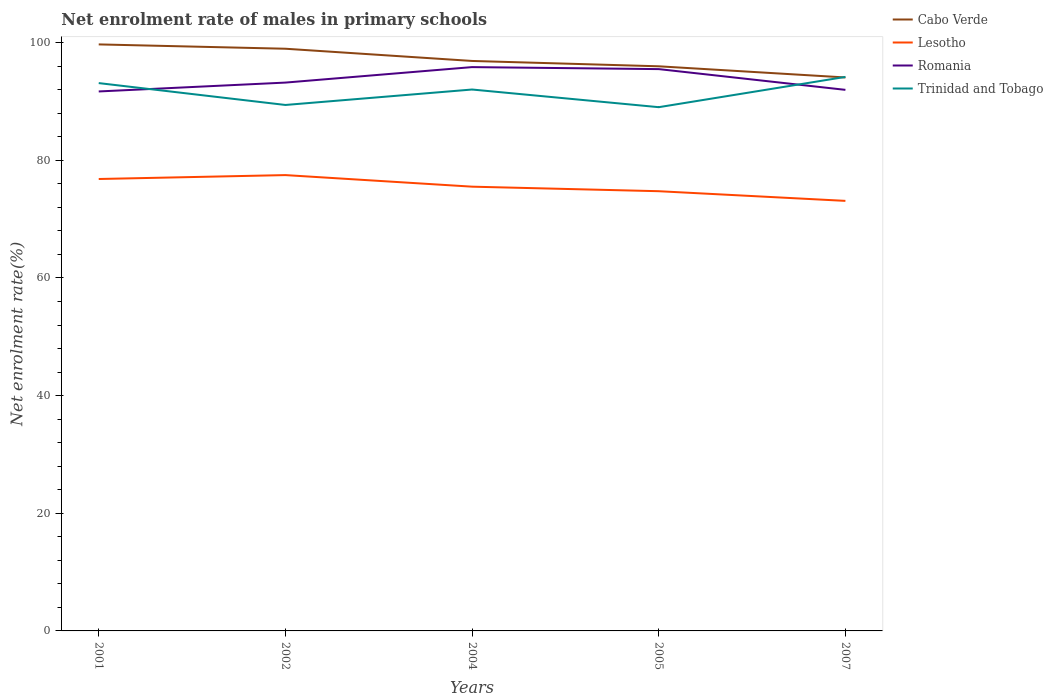Does the line corresponding to Cabo Verde intersect with the line corresponding to Lesotho?
Keep it short and to the point. No. Across all years, what is the maximum net enrolment rate of males in primary schools in Lesotho?
Your answer should be very brief. 73.11. In which year was the net enrolment rate of males in primary schools in Trinidad and Tobago maximum?
Give a very brief answer. 2005. What is the total net enrolment rate of males in primary schools in Lesotho in the graph?
Your response must be concise. 2.74. What is the difference between the highest and the second highest net enrolment rate of males in primary schools in Romania?
Offer a terse response. 4.14. What is the difference between two consecutive major ticks on the Y-axis?
Your answer should be very brief. 20. Does the graph contain any zero values?
Provide a succinct answer. No. Does the graph contain grids?
Offer a very short reply. No. How many legend labels are there?
Offer a very short reply. 4. What is the title of the graph?
Your response must be concise. Net enrolment rate of males in primary schools. What is the label or title of the Y-axis?
Your response must be concise. Net enrolment rate(%). What is the Net enrolment rate(%) in Cabo Verde in 2001?
Offer a terse response. 99.71. What is the Net enrolment rate(%) of Lesotho in 2001?
Make the answer very short. 76.82. What is the Net enrolment rate(%) of Romania in 2001?
Provide a succinct answer. 91.71. What is the Net enrolment rate(%) of Trinidad and Tobago in 2001?
Your response must be concise. 93.13. What is the Net enrolment rate(%) of Cabo Verde in 2002?
Keep it short and to the point. 98.97. What is the Net enrolment rate(%) of Lesotho in 2002?
Ensure brevity in your answer.  77.49. What is the Net enrolment rate(%) of Romania in 2002?
Your answer should be very brief. 93.21. What is the Net enrolment rate(%) of Trinidad and Tobago in 2002?
Make the answer very short. 89.41. What is the Net enrolment rate(%) in Cabo Verde in 2004?
Keep it short and to the point. 96.89. What is the Net enrolment rate(%) in Lesotho in 2004?
Provide a succinct answer. 75.52. What is the Net enrolment rate(%) of Romania in 2004?
Offer a very short reply. 95.85. What is the Net enrolment rate(%) of Trinidad and Tobago in 2004?
Ensure brevity in your answer.  92.04. What is the Net enrolment rate(%) of Cabo Verde in 2005?
Your response must be concise. 95.98. What is the Net enrolment rate(%) in Lesotho in 2005?
Offer a terse response. 74.75. What is the Net enrolment rate(%) in Romania in 2005?
Offer a very short reply. 95.51. What is the Net enrolment rate(%) of Trinidad and Tobago in 2005?
Your response must be concise. 89.03. What is the Net enrolment rate(%) in Cabo Verde in 2007?
Your answer should be compact. 94.08. What is the Net enrolment rate(%) of Lesotho in 2007?
Keep it short and to the point. 73.11. What is the Net enrolment rate(%) in Romania in 2007?
Provide a short and direct response. 91.98. What is the Net enrolment rate(%) of Trinidad and Tobago in 2007?
Offer a very short reply. 94.18. Across all years, what is the maximum Net enrolment rate(%) in Cabo Verde?
Give a very brief answer. 99.71. Across all years, what is the maximum Net enrolment rate(%) in Lesotho?
Give a very brief answer. 77.49. Across all years, what is the maximum Net enrolment rate(%) of Romania?
Keep it short and to the point. 95.85. Across all years, what is the maximum Net enrolment rate(%) of Trinidad and Tobago?
Give a very brief answer. 94.18. Across all years, what is the minimum Net enrolment rate(%) in Cabo Verde?
Offer a terse response. 94.08. Across all years, what is the minimum Net enrolment rate(%) of Lesotho?
Your answer should be compact. 73.11. Across all years, what is the minimum Net enrolment rate(%) in Romania?
Make the answer very short. 91.71. Across all years, what is the minimum Net enrolment rate(%) of Trinidad and Tobago?
Offer a terse response. 89.03. What is the total Net enrolment rate(%) of Cabo Verde in the graph?
Make the answer very short. 485.63. What is the total Net enrolment rate(%) of Lesotho in the graph?
Give a very brief answer. 377.69. What is the total Net enrolment rate(%) of Romania in the graph?
Offer a very short reply. 468.25. What is the total Net enrolment rate(%) of Trinidad and Tobago in the graph?
Ensure brevity in your answer.  457.79. What is the difference between the Net enrolment rate(%) in Cabo Verde in 2001 and that in 2002?
Make the answer very short. 0.74. What is the difference between the Net enrolment rate(%) of Lesotho in 2001 and that in 2002?
Your answer should be compact. -0.66. What is the difference between the Net enrolment rate(%) of Romania in 2001 and that in 2002?
Ensure brevity in your answer.  -1.51. What is the difference between the Net enrolment rate(%) of Trinidad and Tobago in 2001 and that in 2002?
Your answer should be compact. 3.72. What is the difference between the Net enrolment rate(%) in Cabo Verde in 2001 and that in 2004?
Keep it short and to the point. 2.81. What is the difference between the Net enrolment rate(%) of Lesotho in 2001 and that in 2004?
Ensure brevity in your answer.  1.3. What is the difference between the Net enrolment rate(%) of Romania in 2001 and that in 2004?
Keep it short and to the point. -4.14. What is the difference between the Net enrolment rate(%) of Trinidad and Tobago in 2001 and that in 2004?
Provide a succinct answer. 1.09. What is the difference between the Net enrolment rate(%) of Cabo Verde in 2001 and that in 2005?
Make the answer very short. 3.72. What is the difference between the Net enrolment rate(%) of Lesotho in 2001 and that in 2005?
Keep it short and to the point. 2.07. What is the difference between the Net enrolment rate(%) of Romania in 2001 and that in 2005?
Offer a terse response. -3.8. What is the difference between the Net enrolment rate(%) of Trinidad and Tobago in 2001 and that in 2005?
Make the answer very short. 4.09. What is the difference between the Net enrolment rate(%) in Cabo Verde in 2001 and that in 2007?
Give a very brief answer. 5.62. What is the difference between the Net enrolment rate(%) in Lesotho in 2001 and that in 2007?
Keep it short and to the point. 3.72. What is the difference between the Net enrolment rate(%) of Romania in 2001 and that in 2007?
Provide a short and direct response. -0.27. What is the difference between the Net enrolment rate(%) in Trinidad and Tobago in 2001 and that in 2007?
Give a very brief answer. -1.05. What is the difference between the Net enrolment rate(%) in Cabo Verde in 2002 and that in 2004?
Provide a short and direct response. 2.08. What is the difference between the Net enrolment rate(%) of Lesotho in 2002 and that in 2004?
Your answer should be compact. 1.97. What is the difference between the Net enrolment rate(%) of Romania in 2002 and that in 2004?
Your answer should be very brief. -2.63. What is the difference between the Net enrolment rate(%) in Trinidad and Tobago in 2002 and that in 2004?
Your response must be concise. -2.63. What is the difference between the Net enrolment rate(%) in Cabo Verde in 2002 and that in 2005?
Give a very brief answer. 2.99. What is the difference between the Net enrolment rate(%) of Lesotho in 2002 and that in 2005?
Ensure brevity in your answer.  2.74. What is the difference between the Net enrolment rate(%) of Romania in 2002 and that in 2005?
Your answer should be very brief. -2.29. What is the difference between the Net enrolment rate(%) of Trinidad and Tobago in 2002 and that in 2005?
Offer a terse response. 0.38. What is the difference between the Net enrolment rate(%) of Cabo Verde in 2002 and that in 2007?
Your answer should be compact. 4.88. What is the difference between the Net enrolment rate(%) in Lesotho in 2002 and that in 2007?
Your response must be concise. 4.38. What is the difference between the Net enrolment rate(%) of Romania in 2002 and that in 2007?
Offer a very short reply. 1.24. What is the difference between the Net enrolment rate(%) in Trinidad and Tobago in 2002 and that in 2007?
Offer a terse response. -4.77. What is the difference between the Net enrolment rate(%) of Cabo Verde in 2004 and that in 2005?
Your response must be concise. 0.91. What is the difference between the Net enrolment rate(%) of Lesotho in 2004 and that in 2005?
Keep it short and to the point. 0.77. What is the difference between the Net enrolment rate(%) of Romania in 2004 and that in 2005?
Your answer should be compact. 0.34. What is the difference between the Net enrolment rate(%) in Trinidad and Tobago in 2004 and that in 2005?
Your answer should be compact. 3. What is the difference between the Net enrolment rate(%) of Cabo Verde in 2004 and that in 2007?
Offer a very short reply. 2.81. What is the difference between the Net enrolment rate(%) in Lesotho in 2004 and that in 2007?
Offer a very short reply. 2.42. What is the difference between the Net enrolment rate(%) in Romania in 2004 and that in 2007?
Give a very brief answer. 3.87. What is the difference between the Net enrolment rate(%) of Trinidad and Tobago in 2004 and that in 2007?
Ensure brevity in your answer.  -2.14. What is the difference between the Net enrolment rate(%) in Cabo Verde in 2005 and that in 2007?
Your answer should be compact. 1.9. What is the difference between the Net enrolment rate(%) in Lesotho in 2005 and that in 2007?
Your answer should be very brief. 1.64. What is the difference between the Net enrolment rate(%) in Romania in 2005 and that in 2007?
Your answer should be compact. 3.53. What is the difference between the Net enrolment rate(%) of Trinidad and Tobago in 2005 and that in 2007?
Your answer should be compact. -5.15. What is the difference between the Net enrolment rate(%) in Cabo Verde in 2001 and the Net enrolment rate(%) in Lesotho in 2002?
Offer a very short reply. 22.22. What is the difference between the Net enrolment rate(%) of Cabo Verde in 2001 and the Net enrolment rate(%) of Romania in 2002?
Offer a terse response. 6.49. What is the difference between the Net enrolment rate(%) in Cabo Verde in 2001 and the Net enrolment rate(%) in Trinidad and Tobago in 2002?
Offer a terse response. 10.3. What is the difference between the Net enrolment rate(%) of Lesotho in 2001 and the Net enrolment rate(%) of Romania in 2002?
Keep it short and to the point. -16.39. What is the difference between the Net enrolment rate(%) of Lesotho in 2001 and the Net enrolment rate(%) of Trinidad and Tobago in 2002?
Make the answer very short. -12.59. What is the difference between the Net enrolment rate(%) in Romania in 2001 and the Net enrolment rate(%) in Trinidad and Tobago in 2002?
Give a very brief answer. 2.3. What is the difference between the Net enrolment rate(%) of Cabo Verde in 2001 and the Net enrolment rate(%) of Lesotho in 2004?
Keep it short and to the point. 24.18. What is the difference between the Net enrolment rate(%) in Cabo Verde in 2001 and the Net enrolment rate(%) in Romania in 2004?
Your answer should be compact. 3.86. What is the difference between the Net enrolment rate(%) of Cabo Verde in 2001 and the Net enrolment rate(%) of Trinidad and Tobago in 2004?
Provide a short and direct response. 7.67. What is the difference between the Net enrolment rate(%) of Lesotho in 2001 and the Net enrolment rate(%) of Romania in 2004?
Offer a very short reply. -19.02. What is the difference between the Net enrolment rate(%) in Lesotho in 2001 and the Net enrolment rate(%) in Trinidad and Tobago in 2004?
Provide a succinct answer. -15.21. What is the difference between the Net enrolment rate(%) in Romania in 2001 and the Net enrolment rate(%) in Trinidad and Tobago in 2004?
Give a very brief answer. -0.33. What is the difference between the Net enrolment rate(%) in Cabo Verde in 2001 and the Net enrolment rate(%) in Lesotho in 2005?
Your response must be concise. 24.96. What is the difference between the Net enrolment rate(%) in Cabo Verde in 2001 and the Net enrolment rate(%) in Romania in 2005?
Your response must be concise. 4.2. What is the difference between the Net enrolment rate(%) in Cabo Verde in 2001 and the Net enrolment rate(%) in Trinidad and Tobago in 2005?
Your answer should be compact. 10.67. What is the difference between the Net enrolment rate(%) of Lesotho in 2001 and the Net enrolment rate(%) of Romania in 2005?
Give a very brief answer. -18.68. What is the difference between the Net enrolment rate(%) in Lesotho in 2001 and the Net enrolment rate(%) in Trinidad and Tobago in 2005?
Make the answer very short. -12.21. What is the difference between the Net enrolment rate(%) of Romania in 2001 and the Net enrolment rate(%) of Trinidad and Tobago in 2005?
Offer a very short reply. 2.67. What is the difference between the Net enrolment rate(%) of Cabo Verde in 2001 and the Net enrolment rate(%) of Lesotho in 2007?
Your answer should be very brief. 26.6. What is the difference between the Net enrolment rate(%) of Cabo Verde in 2001 and the Net enrolment rate(%) of Romania in 2007?
Keep it short and to the point. 7.73. What is the difference between the Net enrolment rate(%) in Cabo Verde in 2001 and the Net enrolment rate(%) in Trinidad and Tobago in 2007?
Offer a terse response. 5.53. What is the difference between the Net enrolment rate(%) in Lesotho in 2001 and the Net enrolment rate(%) in Romania in 2007?
Give a very brief answer. -15.15. What is the difference between the Net enrolment rate(%) in Lesotho in 2001 and the Net enrolment rate(%) in Trinidad and Tobago in 2007?
Provide a short and direct response. -17.36. What is the difference between the Net enrolment rate(%) in Romania in 2001 and the Net enrolment rate(%) in Trinidad and Tobago in 2007?
Make the answer very short. -2.47. What is the difference between the Net enrolment rate(%) in Cabo Verde in 2002 and the Net enrolment rate(%) in Lesotho in 2004?
Your response must be concise. 23.45. What is the difference between the Net enrolment rate(%) of Cabo Verde in 2002 and the Net enrolment rate(%) of Romania in 2004?
Your response must be concise. 3.12. What is the difference between the Net enrolment rate(%) of Cabo Verde in 2002 and the Net enrolment rate(%) of Trinidad and Tobago in 2004?
Give a very brief answer. 6.93. What is the difference between the Net enrolment rate(%) in Lesotho in 2002 and the Net enrolment rate(%) in Romania in 2004?
Offer a terse response. -18.36. What is the difference between the Net enrolment rate(%) of Lesotho in 2002 and the Net enrolment rate(%) of Trinidad and Tobago in 2004?
Provide a succinct answer. -14.55. What is the difference between the Net enrolment rate(%) of Romania in 2002 and the Net enrolment rate(%) of Trinidad and Tobago in 2004?
Keep it short and to the point. 1.18. What is the difference between the Net enrolment rate(%) of Cabo Verde in 2002 and the Net enrolment rate(%) of Lesotho in 2005?
Ensure brevity in your answer.  24.22. What is the difference between the Net enrolment rate(%) in Cabo Verde in 2002 and the Net enrolment rate(%) in Romania in 2005?
Make the answer very short. 3.46. What is the difference between the Net enrolment rate(%) of Cabo Verde in 2002 and the Net enrolment rate(%) of Trinidad and Tobago in 2005?
Give a very brief answer. 9.93. What is the difference between the Net enrolment rate(%) in Lesotho in 2002 and the Net enrolment rate(%) in Romania in 2005?
Ensure brevity in your answer.  -18.02. What is the difference between the Net enrolment rate(%) of Lesotho in 2002 and the Net enrolment rate(%) of Trinidad and Tobago in 2005?
Provide a succinct answer. -11.55. What is the difference between the Net enrolment rate(%) of Romania in 2002 and the Net enrolment rate(%) of Trinidad and Tobago in 2005?
Give a very brief answer. 4.18. What is the difference between the Net enrolment rate(%) in Cabo Verde in 2002 and the Net enrolment rate(%) in Lesotho in 2007?
Provide a short and direct response. 25.86. What is the difference between the Net enrolment rate(%) in Cabo Verde in 2002 and the Net enrolment rate(%) in Romania in 2007?
Offer a terse response. 6.99. What is the difference between the Net enrolment rate(%) of Cabo Verde in 2002 and the Net enrolment rate(%) of Trinidad and Tobago in 2007?
Your answer should be compact. 4.79. What is the difference between the Net enrolment rate(%) of Lesotho in 2002 and the Net enrolment rate(%) of Romania in 2007?
Keep it short and to the point. -14.49. What is the difference between the Net enrolment rate(%) of Lesotho in 2002 and the Net enrolment rate(%) of Trinidad and Tobago in 2007?
Your answer should be compact. -16.69. What is the difference between the Net enrolment rate(%) of Romania in 2002 and the Net enrolment rate(%) of Trinidad and Tobago in 2007?
Offer a very short reply. -0.96. What is the difference between the Net enrolment rate(%) of Cabo Verde in 2004 and the Net enrolment rate(%) of Lesotho in 2005?
Make the answer very short. 22.14. What is the difference between the Net enrolment rate(%) of Cabo Verde in 2004 and the Net enrolment rate(%) of Romania in 2005?
Provide a short and direct response. 1.38. What is the difference between the Net enrolment rate(%) of Cabo Verde in 2004 and the Net enrolment rate(%) of Trinidad and Tobago in 2005?
Your answer should be compact. 7.86. What is the difference between the Net enrolment rate(%) in Lesotho in 2004 and the Net enrolment rate(%) in Romania in 2005?
Your response must be concise. -19.98. What is the difference between the Net enrolment rate(%) in Lesotho in 2004 and the Net enrolment rate(%) in Trinidad and Tobago in 2005?
Give a very brief answer. -13.51. What is the difference between the Net enrolment rate(%) of Romania in 2004 and the Net enrolment rate(%) of Trinidad and Tobago in 2005?
Keep it short and to the point. 6.81. What is the difference between the Net enrolment rate(%) of Cabo Verde in 2004 and the Net enrolment rate(%) of Lesotho in 2007?
Ensure brevity in your answer.  23.79. What is the difference between the Net enrolment rate(%) in Cabo Verde in 2004 and the Net enrolment rate(%) in Romania in 2007?
Make the answer very short. 4.91. What is the difference between the Net enrolment rate(%) of Cabo Verde in 2004 and the Net enrolment rate(%) of Trinidad and Tobago in 2007?
Provide a short and direct response. 2.71. What is the difference between the Net enrolment rate(%) in Lesotho in 2004 and the Net enrolment rate(%) in Romania in 2007?
Offer a terse response. -16.46. What is the difference between the Net enrolment rate(%) of Lesotho in 2004 and the Net enrolment rate(%) of Trinidad and Tobago in 2007?
Your answer should be compact. -18.66. What is the difference between the Net enrolment rate(%) in Romania in 2004 and the Net enrolment rate(%) in Trinidad and Tobago in 2007?
Offer a very short reply. 1.67. What is the difference between the Net enrolment rate(%) of Cabo Verde in 2005 and the Net enrolment rate(%) of Lesotho in 2007?
Give a very brief answer. 22.88. What is the difference between the Net enrolment rate(%) of Cabo Verde in 2005 and the Net enrolment rate(%) of Romania in 2007?
Provide a succinct answer. 4. What is the difference between the Net enrolment rate(%) in Cabo Verde in 2005 and the Net enrolment rate(%) in Trinidad and Tobago in 2007?
Your answer should be very brief. 1.8. What is the difference between the Net enrolment rate(%) in Lesotho in 2005 and the Net enrolment rate(%) in Romania in 2007?
Provide a succinct answer. -17.23. What is the difference between the Net enrolment rate(%) of Lesotho in 2005 and the Net enrolment rate(%) of Trinidad and Tobago in 2007?
Your response must be concise. -19.43. What is the difference between the Net enrolment rate(%) of Romania in 2005 and the Net enrolment rate(%) of Trinidad and Tobago in 2007?
Keep it short and to the point. 1.33. What is the average Net enrolment rate(%) of Cabo Verde per year?
Provide a succinct answer. 97.13. What is the average Net enrolment rate(%) in Lesotho per year?
Offer a terse response. 75.54. What is the average Net enrolment rate(%) of Romania per year?
Provide a short and direct response. 93.65. What is the average Net enrolment rate(%) in Trinidad and Tobago per year?
Your response must be concise. 91.56. In the year 2001, what is the difference between the Net enrolment rate(%) in Cabo Verde and Net enrolment rate(%) in Lesotho?
Ensure brevity in your answer.  22.88. In the year 2001, what is the difference between the Net enrolment rate(%) in Cabo Verde and Net enrolment rate(%) in Romania?
Your answer should be very brief. 8. In the year 2001, what is the difference between the Net enrolment rate(%) of Cabo Verde and Net enrolment rate(%) of Trinidad and Tobago?
Offer a terse response. 6.58. In the year 2001, what is the difference between the Net enrolment rate(%) in Lesotho and Net enrolment rate(%) in Romania?
Keep it short and to the point. -14.88. In the year 2001, what is the difference between the Net enrolment rate(%) of Lesotho and Net enrolment rate(%) of Trinidad and Tobago?
Make the answer very short. -16.3. In the year 2001, what is the difference between the Net enrolment rate(%) of Romania and Net enrolment rate(%) of Trinidad and Tobago?
Give a very brief answer. -1.42. In the year 2002, what is the difference between the Net enrolment rate(%) of Cabo Verde and Net enrolment rate(%) of Lesotho?
Your answer should be compact. 21.48. In the year 2002, what is the difference between the Net enrolment rate(%) of Cabo Verde and Net enrolment rate(%) of Romania?
Your response must be concise. 5.75. In the year 2002, what is the difference between the Net enrolment rate(%) of Cabo Verde and Net enrolment rate(%) of Trinidad and Tobago?
Your response must be concise. 9.56. In the year 2002, what is the difference between the Net enrolment rate(%) of Lesotho and Net enrolment rate(%) of Romania?
Your answer should be compact. -15.73. In the year 2002, what is the difference between the Net enrolment rate(%) in Lesotho and Net enrolment rate(%) in Trinidad and Tobago?
Provide a succinct answer. -11.92. In the year 2002, what is the difference between the Net enrolment rate(%) in Romania and Net enrolment rate(%) in Trinidad and Tobago?
Offer a very short reply. 3.8. In the year 2004, what is the difference between the Net enrolment rate(%) of Cabo Verde and Net enrolment rate(%) of Lesotho?
Your response must be concise. 21.37. In the year 2004, what is the difference between the Net enrolment rate(%) of Cabo Verde and Net enrolment rate(%) of Romania?
Give a very brief answer. 1.04. In the year 2004, what is the difference between the Net enrolment rate(%) in Cabo Verde and Net enrolment rate(%) in Trinidad and Tobago?
Give a very brief answer. 4.85. In the year 2004, what is the difference between the Net enrolment rate(%) of Lesotho and Net enrolment rate(%) of Romania?
Provide a succinct answer. -20.32. In the year 2004, what is the difference between the Net enrolment rate(%) in Lesotho and Net enrolment rate(%) in Trinidad and Tobago?
Ensure brevity in your answer.  -16.52. In the year 2004, what is the difference between the Net enrolment rate(%) in Romania and Net enrolment rate(%) in Trinidad and Tobago?
Offer a very short reply. 3.81. In the year 2005, what is the difference between the Net enrolment rate(%) of Cabo Verde and Net enrolment rate(%) of Lesotho?
Your response must be concise. 21.23. In the year 2005, what is the difference between the Net enrolment rate(%) of Cabo Verde and Net enrolment rate(%) of Romania?
Offer a very short reply. 0.48. In the year 2005, what is the difference between the Net enrolment rate(%) in Cabo Verde and Net enrolment rate(%) in Trinidad and Tobago?
Offer a terse response. 6.95. In the year 2005, what is the difference between the Net enrolment rate(%) of Lesotho and Net enrolment rate(%) of Romania?
Your answer should be very brief. -20.76. In the year 2005, what is the difference between the Net enrolment rate(%) of Lesotho and Net enrolment rate(%) of Trinidad and Tobago?
Your response must be concise. -14.28. In the year 2005, what is the difference between the Net enrolment rate(%) in Romania and Net enrolment rate(%) in Trinidad and Tobago?
Your answer should be very brief. 6.47. In the year 2007, what is the difference between the Net enrolment rate(%) of Cabo Verde and Net enrolment rate(%) of Lesotho?
Your answer should be compact. 20.98. In the year 2007, what is the difference between the Net enrolment rate(%) of Cabo Verde and Net enrolment rate(%) of Romania?
Your answer should be compact. 2.11. In the year 2007, what is the difference between the Net enrolment rate(%) of Cabo Verde and Net enrolment rate(%) of Trinidad and Tobago?
Offer a very short reply. -0.1. In the year 2007, what is the difference between the Net enrolment rate(%) in Lesotho and Net enrolment rate(%) in Romania?
Give a very brief answer. -18.87. In the year 2007, what is the difference between the Net enrolment rate(%) in Lesotho and Net enrolment rate(%) in Trinidad and Tobago?
Provide a short and direct response. -21.07. In the year 2007, what is the difference between the Net enrolment rate(%) of Romania and Net enrolment rate(%) of Trinidad and Tobago?
Offer a very short reply. -2.2. What is the ratio of the Net enrolment rate(%) in Cabo Verde in 2001 to that in 2002?
Ensure brevity in your answer.  1.01. What is the ratio of the Net enrolment rate(%) in Romania in 2001 to that in 2002?
Give a very brief answer. 0.98. What is the ratio of the Net enrolment rate(%) of Trinidad and Tobago in 2001 to that in 2002?
Offer a very short reply. 1.04. What is the ratio of the Net enrolment rate(%) of Cabo Verde in 2001 to that in 2004?
Offer a very short reply. 1.03. What is the ratio of the Net enrolment rate(%) of Lesotho in 2001 to that in 2004?
Offer a terse response. 1.02. What is the ratio of the Net enrolment rate(%) in Romania in 2001 to that in 2004?
Ensure brevity in your answer.  0.96. What is the ratio of the Net enrolment rate(%) of Trinidad and Tobago in 2001 to that in 2004?
Your answer should be compact. 1.01. What is the ratio of the Net enrolment rate(%) of Cabo Verde in 2001 to that in 2005?
Offer a terse response. 1.04. What is the ratio of the Net enrolment rate(%) of Lesotho in 2001 to that in 2005?
Make the answer very short. 1.03. What is the ratio of the Net enrolment rate(%) in Romania in 2001 to that in 2005?
Make the answer very short. 0.96. What is the ratio of the Net enrolment rate(%) in Trinidad and Tobago in 2001 to that in 2005?
Provide a succinct answer. 1.05. What is the ratio of the Net enrolment rate(%) of Cabo Verde in 2001 to that in 2007?
Your response must be concise. 1.06. What is the ratio of the Net enrolment rate(%) of Lesotho in 2001 to that in 2007?
Your answer should be very brief. 1.05. What is the ratio of the Net enrolment rate(%) of Cabo Verde in 2002 to that in 2004?
Ensure brevity in your answer.  1.02. What is the ratio of the Net enrolment rate(%) in Romania in 2002 to that in 2004?
Ensure brevity in your answer.  0.97. What is the ratio of the Net enrolment rate(%) in Trinidad and Tobago in 2002 to that in 2004?
Give a very brief answer. 0.97. What is the ratio of the Net enrolment rate(%) in Cabo Verde in 2002 to that in 2005?
Keep it short and to the point. 1.03. What is the ratio of the Net enrolment rate(%) in Lesotho in 2002 to that in 2005?
Make the answer very short. 1.04. What is the ratio of the Net enrolment rate(%) in Trinidad and Tobago in 2002 to that in 2005?
Give a very brief answer. 1. What is the ratio of the Net enrolment rate(%) in Cabo Verde in 2002 to that in 2007?
Provide a succinct answer. 1.05. What is the ratio of the Net enrolment rate(%) in Lesotho in 2002 to that in 2007?
Make the answer very short. 1.06. What is the ratio of the Net enrolment rate(%) in Romania in 2002 to that in 2007?
Your answer should be compact. 1.01. What is the ratio of the Net enrolment rate(%) of Trinidad and Tobago in 2002 to that in 2007?
Provide a succinct answer. 0.95. What is the ratio of the Net enrolment rate(%) of Cabo Verde in 2004 to that in 2005?
Make the answer very short. 1.01. What is the ratio of the Net enrolment rate(%) of Lesotho in 2004 to that in 2005?
Make the answer very short. 1.01. What is the ratio of the Net enrolment rate(%) in Romania in 2004 to that in 2005?
Provide a succinct answer. 1. What is the ratio of the Net enrolment rate(%) in Trinidad and Tobago in 2004 to that in 2005?
Offer a very short reply. 1.03. What is the ratio of the Net enrolment rate(%) in Cabo Verde in 2004 to that in 2007?
Ensure brevity in your answer.  1.03. What is the ratio of the Net enrolment rate(%) in Lesotho in 2004 to that in 2007?
Ensure brevity in your answer.  1.03. What is the ratio of the Net enrolment rate(%) in Romania in 2004 to that in 2007?
Keep it short and to the point. 1.04. What is the ratio of the Net enrolment rate(%) of Trinidad and Tobago in 2004 to that in 2007?
Offer a terse response. 0.98. What is the ratio of the Net enrolment rate(%) of Cabo Verde in 2005 to that in 2007?
Your answer should be compact. 1.02. What is the ratio of the Net enrolment rate(%) in Lesotho in 2005 to that in 2007?
Your answer should be very brief. 1.02. What is the ratio of the Net enrolment rate(%) in Romania in 2005 to that in 2007?
Ensure brevity in your answer.  1.04. What is the ratio of the Net enrolment rate(%) in Trinidad and Tobago in 2005 to that in 2007?
Give a very brief answer. 0.95. What is the difference between the highest and the second highest Net enrolment rate(%) of Cabo Verde?
Your response must be concise. 0.74. What is the difference between the highest and the second highest Net enrolment rate(%) in Lesotho?
Offer a terse response. 0.66. What is the difference between the highest and the second highest Net enrolment rate(%) of Romania?
Offer a very short reply. 0.34. What is the difference between the highest and the second highest Net enrolment rate(%) in Trinidad and Tobago?
Give a very brief answer. 1.05. What is the difference between the highest and the lowest Net enrolment rate(%) in Cabo Verde?
Keep it short and to the point. 5.62. What is the difference between the highest and the lowest Net enrolment rate(%) in Lesotho?
Your answer should be very brief. 4.38. What is the difference between the highest and the lowest Net enrolment rate(%) in Romania?
Keep it short and to the point. 4.14. What is the difference between the highest and the lowest Net enrolment rate(%) of Trinidad and Tobago?
Your response must be concise. 5.15. 